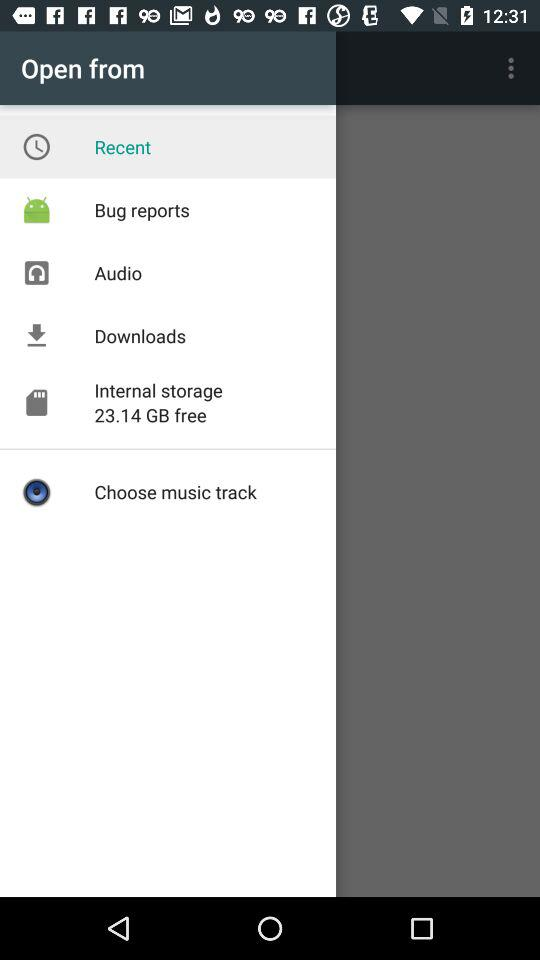How much internal storage is free? The size of free internal storage is 23.14 GB. 